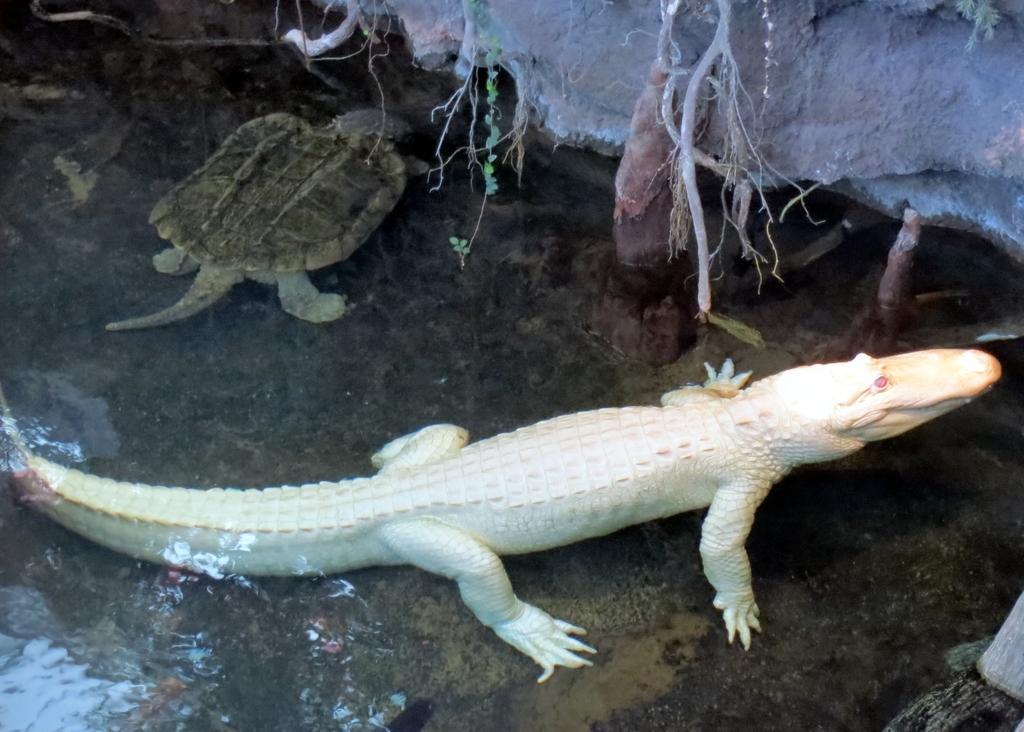Describe this image in one or two sentences. In this image there is a lizard in the middle. Beside it there is a small crocodile. On the right side top there is a stone. On the stone there are small plants. At the bottom it looks like a water. 